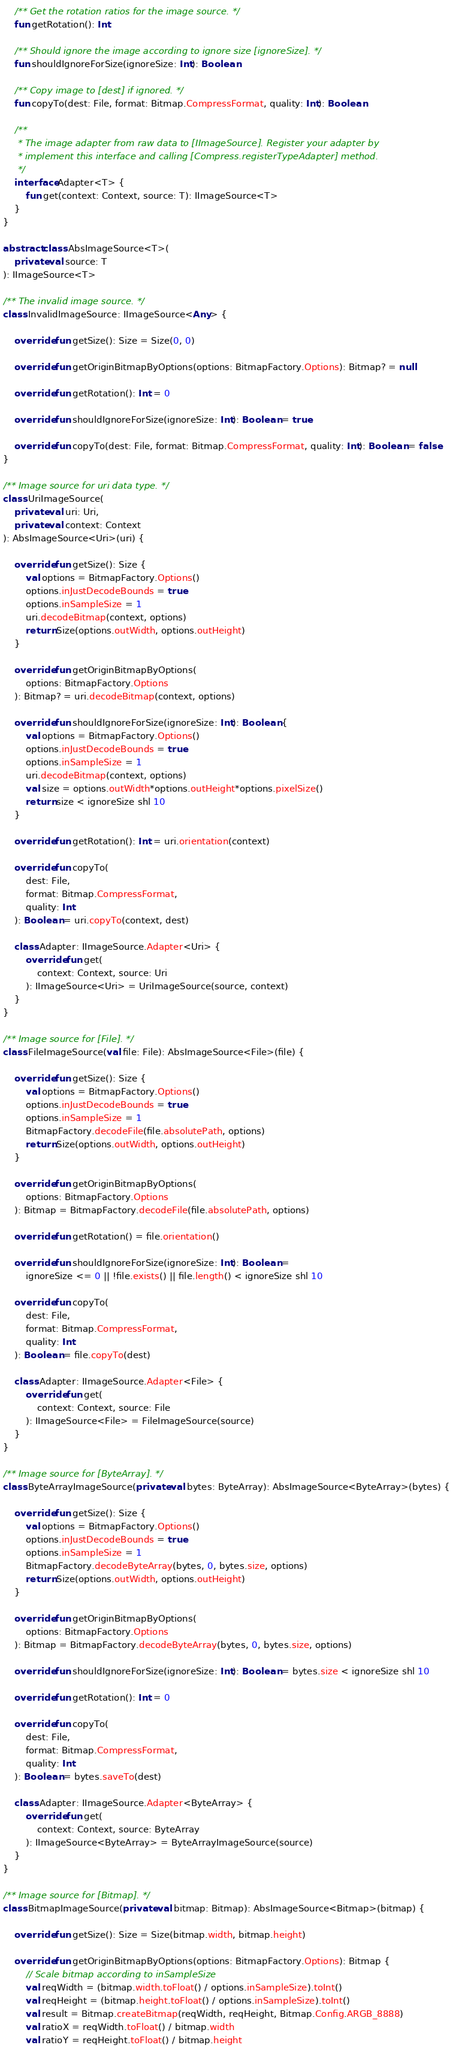Convert code to text. <code><loc_0><loc_0><loc_500><loc_500><_Kotlin_>    /** Get the rotation ratios for the image source. */
    fun getRotation(): Int

    /** Should ignore the image according to ignore size [ignoreSize]. */
    fun shouldIgnoreForSize(ignoreSize: Int): Boolean

    /** Copy image to [dest] if ignored. */
    fun copyTo(dest: File, format: Bitmap.CompressFormat, quality: Int): Boolean

    /**
     * The image adapter from raw data to [IImageSource]. Register your adapter by
     * implement this interface and calling [Compress.registerTypeAdapter] method.
     */
    interface Adapter<T> {
        fun get(context: Context, source: T): IImageSource<T>
    }
}

abstract class AbsImageSource<T>(
    private val source: T
): IImageSource<T>

/** The invalid image source. */
class InvalidImageSource: IImageSource<Any> {

    override fun getSize(): Size = Size(0, 0)

    override fun getOriginBitmapByOptions(options: BitmapFactory.Options): Bitmap? = null

    override fun getRotation(): Int = 0

    override fun shouldIgnoreForSize(ignoreSize: Int): Boolean = true

    override fun copyTo(dest: File, format: Bitmap.CompressFormat, quality: Int): Boolean = false
}

/** Image source for uri data type. */
class UriImageSource(
    private val uri: Uri,
    private val context: Context
): AbsImageSource<Uri>(uri) {

    override fun getSize(): Size {
        val options = BitmapFactory.Options()
        options.inJustDecodeBounds = true
        options.inSampleSize = 1
        uri.decodeBitmap(context, options)
        return Size(options.outWidth, options.outHeight)
    }

    override fun getOriginBitmapByOptions(
        options: BitmapFactory.Options
    ): Bitmap? = uri.decodeBitmap(context, options)

    override fun shouldIgnoreForSize(ignoreSize: Int): Boolean {
        val options = BitmapFactory.Options()
        options.inJustDecodeBounds = true
        options.inSampleSize = 1
        uri.decodeBitmap(context, options)
        val size = options.outWidth*options.outHeight*options.pixelSize()
        return size < ignoreSize shl 10
    }

    override fun getRotation(): Int = uri.orientation(context)

    override fun copyTo(
        dest: File,
        format: Bitmap.CompressFormat,
        quality: Int
    ): Boolean = uri.copyTo(context, dest)

    class Adapter: IImageSource.Adapter<Uri> {
        override fun get(
            context: Context, source: Uri
        ): IImageSource<Uri> = UriImageSource(source, context)
    }
}

/** Image source for [File]. */
class FileImageSource(val file: File): AbsImageSource<File>(file) {

    override fun getSize(): Size {
        val options = BitmapFactory.Options()
        options.inJustDecodeBounds = true
        options.inSampleSize = 1
        BitmapFactory.decodeFile(file.absolutePath, options)
        return Size(options.outWidth, options.outHeight)
    }

    override fun getOriginBitmapByOptions(
        options: BitmapFactory.Options
    ): Bitmap = BitmapFactory.decodeFile(file.absolutePath, options)

    override fun getRotation() = file.orientation()

    override fun shouldIgnoreForSize(ignoreSize: Int): Boolean =
        ignoreSize <= 0 || !file.exists() || file.length() < ignoreSize shl 10

    override fun copyTo(
        dest: File,
        format: Bitmap.CompressFormat,
        quality: Int
    ): Boolean = file.copyTo(dest)

    class Adapter: IImageSource.Adapter<File> {
        override fun get(
            context: Context, source: File
        ): IImageSource<File> = FileImageSource(source)
    }
}

/** Image source for [ByteArray]. */
class ByteArrayImageSource(private val bytes: ByteArray): AbsImageSource<ByteArray>(bytes) {

    override fun getSize(): Size {
        val options = BitmapFactory.Options()
        options.inJustDecodeBounds = true
        options.inSampleSize = 1
        BitmapFactory.decodeByteArray(bytes, 0, bytes.size, options)
        return Size(options.outWidth, options.outHeight)
    }

    override fun getOriginBitmapByOptions(
        options: BitmapFactory.Options
    ): Bitmap = BitmapFactory.decodeByteArray(bytes, 0, bytes.size, options)

    override fun shouldIgnoreForSize(ignoreSize: Int): Boolean = bytes.size < ignoreSize shl 10

    override fun getRotation(): Int = 0

    override fun copyTo(
        dest: File,
        format: Bitmap.CompressFormat,
        quality: Int
    ): Boolean = bytes.saveTo(dest)

    class Adapter: IImageSource.Adapter<ByteArray> {
        override fun get(
            context: Context, source: ByteArray
        ): IImageSource<ByteArray> = ByteArrayImageSource(source)
    }
}

/** Image source for [Bitmap]. */
class BitmapImageSource(private val bitmap: Bitmap): AbsImageSource<Bitmap>(bitmap) {

    override fun getSize(): Size = Size(bitmap.width, bitmap.height)

    override fun getOriginBitmapByOptions(options: BitmapFactory.Options): Bitmap {
        // Scale bitmap according to inSampleSize
        val reqWidth = (bitmap.width.toFloat() / options.inSampleSize).toInt()
        val reqHeight = (bitmap.height.toFloat() / options.inSampleSize).toInt()
        val result = Bitmap.createBitmap(reqWidth, reqHeight, Bitmap.Config.ARGB_8888)
        val ratioX = reqWidth.toFloat() / bitmap.width
        val ratioY = reqHeight.toFloat() / bitmap.height</code> 